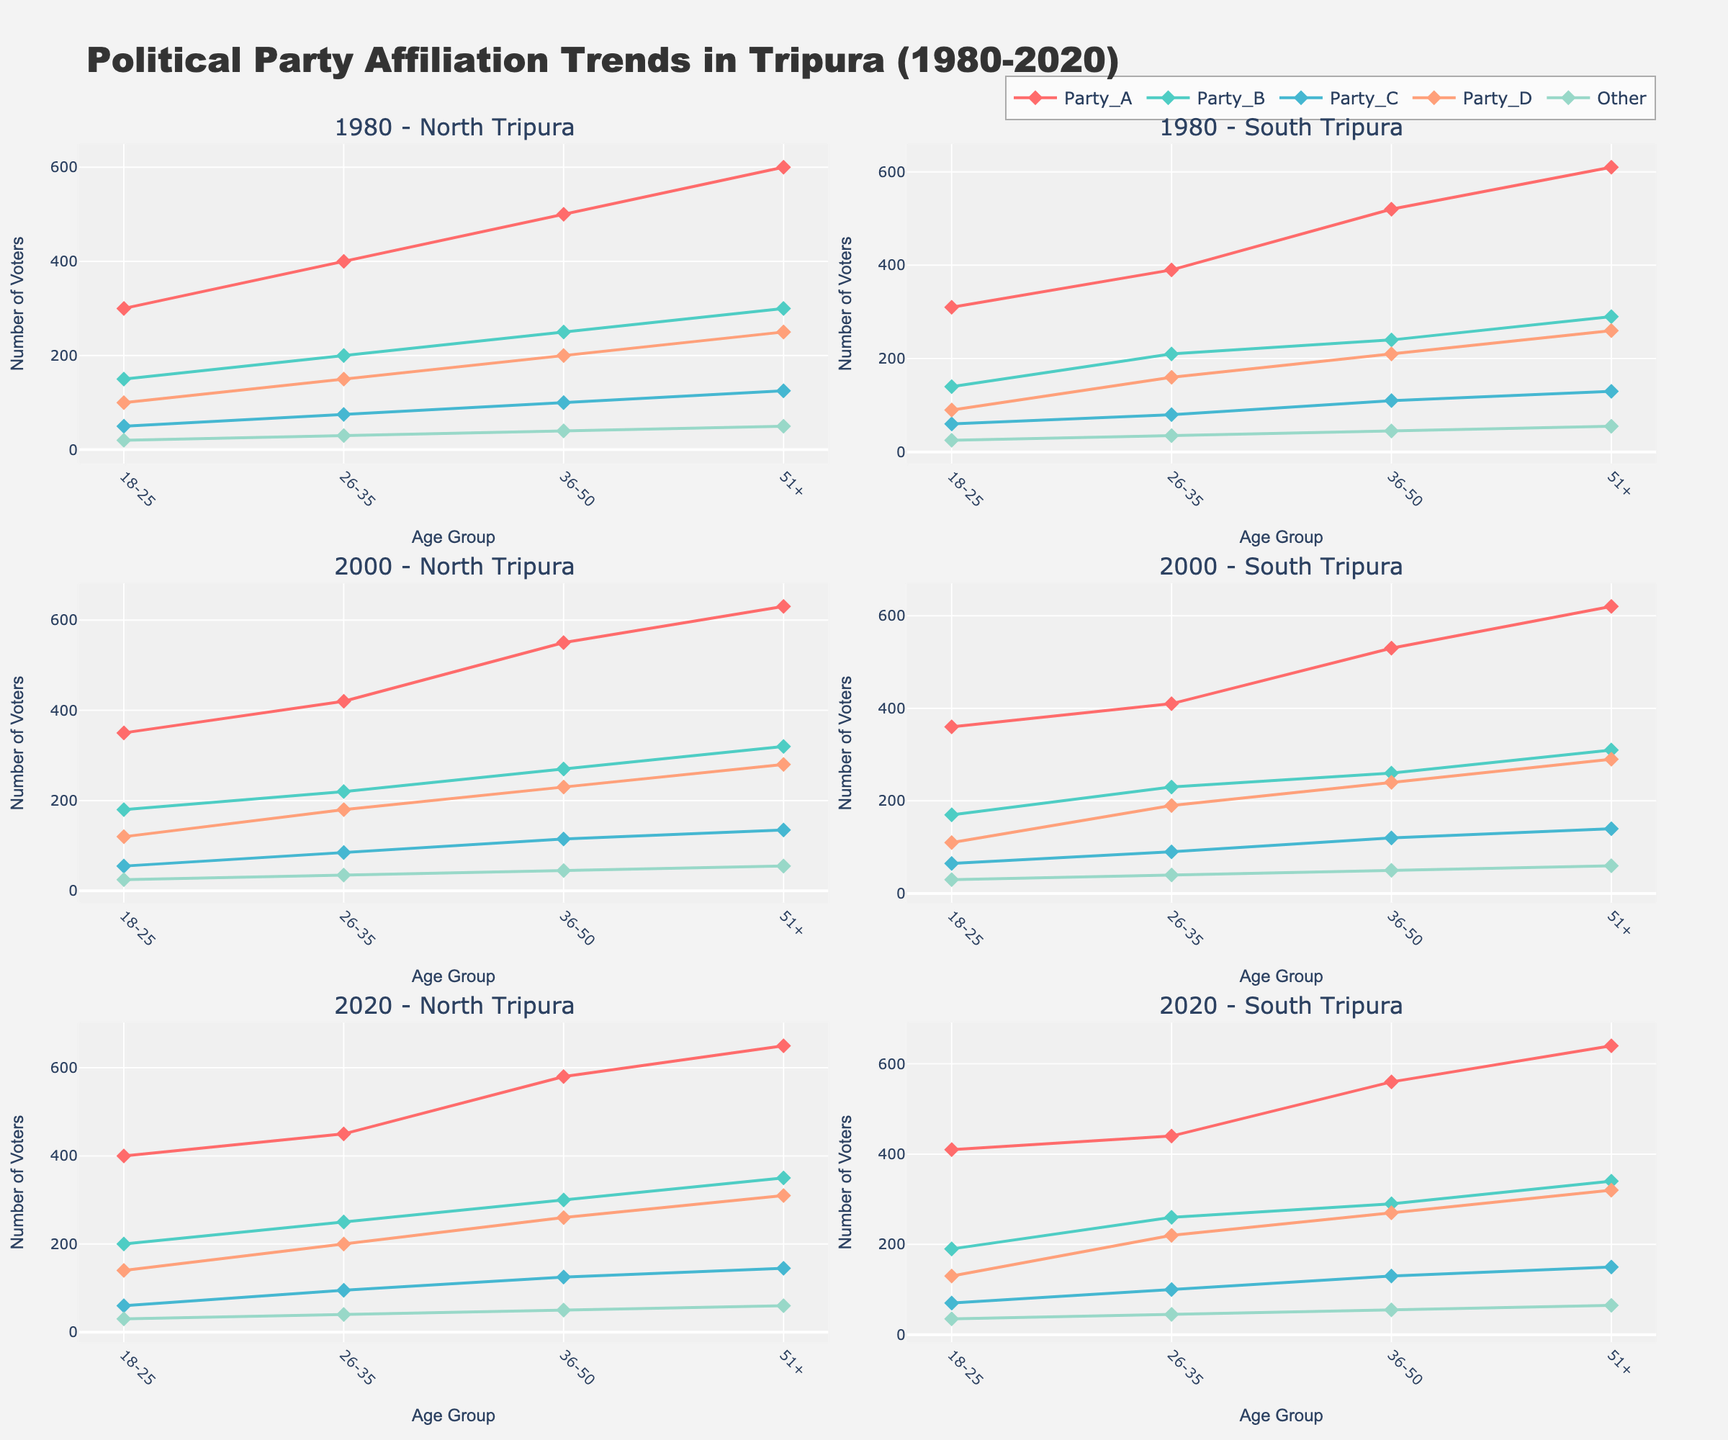Which region has the highest number of voters for Party A in 2020 within the age group 18-25? Observe the subplot for 2020 and compare the values of Party A for the age group 18-25 in both North Tripura and South Tripura. The number of voters for Party A is higher in South Tripura.
Answer: South Tripura How did the number of voters for Party B change from 1980 to 2020 in North Tripura for the age group 51+? Compare the number of voters for Party B in North Tripura reported in 1980 and 2020 for the 51+ age group. In 1980, there were 300 voters, and in 2020, there are 350 voters, showing an increase.
Answer: Increased What is the overall trend for Party C voters in South Tripura from 1980 to 2020 for the age group 36-50? Compare the subplots of South Tripura from 1980, 2000, and 2020 for Party C in the age group 36-50. Notice the increase in voter numbers from 1980 (110) to 2000 (120) to 2020 (130).
Answer: Increasing Which party had the smallest number of voters in the 26-35 age group in 1980 in North Tripura? Check the values for all parties in the 1980 North Tripura subplot for the 26-35 age group. Party C has the smallest number of voters, with 75.
Answer: Party C Compare the number of voters for Party D between North and South Tripura in 2000 for the age group 18-25. Which one is higher? Look at the 2000 subplots for both regions and compare the values for Party D in the age group 18-25. North Tripura has 120 voters while South Tripura has 110 voters.
Answer: North Tripura 